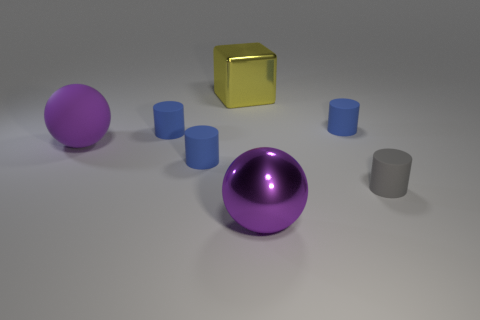Subtract all tiny gray rubber cylinders. How many cylinders are left? 3 Subtract all purple cubes. How many blue cylinders are left? 3 Subtract 1 spheres. How many spheres are left? 1 Subtract all gray cylinders. How many cylinders are left? 3 Add 1 purple shiny things. How many objects exist? 8 Add 5 big purple metallic objects. How many big purple metallic objects are left? 6 Add 1 small rubber cylinders. How many small rubber cylinders exist? 5 Subtract 0 purple cylinders. How many objects are left? 7 Subtract all blocks. How many objects are left? 6 Subtract all yellow cylinders. Subtract all purple cubes. How many cylinders are left? 4 